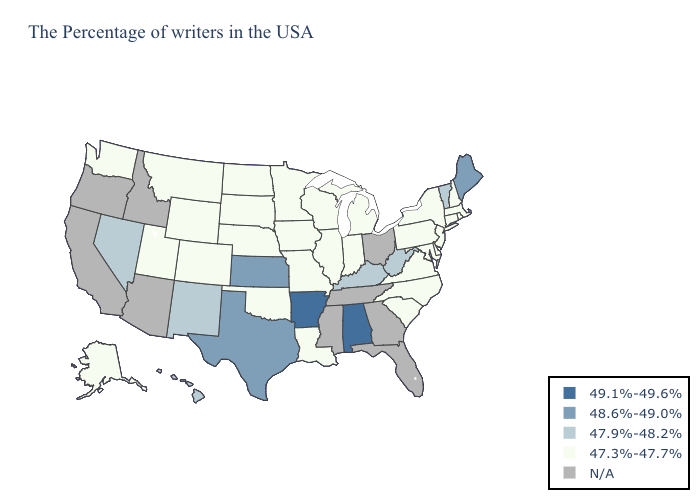What is the highest value in the MidWest ?
Keep it brief. 48.6%-49.0%. Does Nebraska have the lowest value in the USA?
Short answer required. Yes. Name the states that have a value in the range 48.6%-49.0%?
Answer briefly. Maine, Kansas, Texas. Which states have the highest value in the USA?
Write a very short answer. Alabama, Arkansas. Does the first symbol in the legend represent the smallest category?
Keep it brief. No. Which states have the lowest value in the USA?
Give a very brief answer. Massachusetts, Rhode Island, New Hampshire, Connecticut, New York, New Jersey, Delaware, Maryland, Pennsylvania, Virginia, North Carolina, South Carolina, Michigan, Indiana, Wisconsin, Illinois, Louisiana, Missouri, Minnesota, Iowa, Nebraska, Oklahoma, South Dakota, North Dakota, Wyoming, Colorado, Utah, Montana, Washington, Alaska. Which states have the lowest value in the USA?
Be succinct. Massachusetts, Rhode Island, New Hampshire, Connecticut, New York, New Jersey, Delaware, Maryland, Pennsylvania, Virginia, North Carolina, South Carolina, Michigan, Indiana, Wisconsin, Illinois, Louisiana, Missouri, Minnesota, Iowa, Nebraska, Oklahoma, South Dakota, North Dakota, Wyoming, Colorado, Utah, Montana, Washington, Alaska. Name the states that have a value in the range 48.6%-49.0%?
Short answer required. Maine, Kansas, Texas. What is the lowest value in the Northeast?
Write a very short answer. 47.3%-47.7%. Does the first symbol in the legend represent the smallest category?
Write a very short answer. No. Which states hav the highest value in the Northeast?
Short answer required. Maine. What is the lowest value in the USA?
Be succinct. 47.3%-47.7%. What is the value of Mississippi?
Be succinct. N/A. What is the lowest value in the West?
Quick response, please. 47.3%-47.7%. 